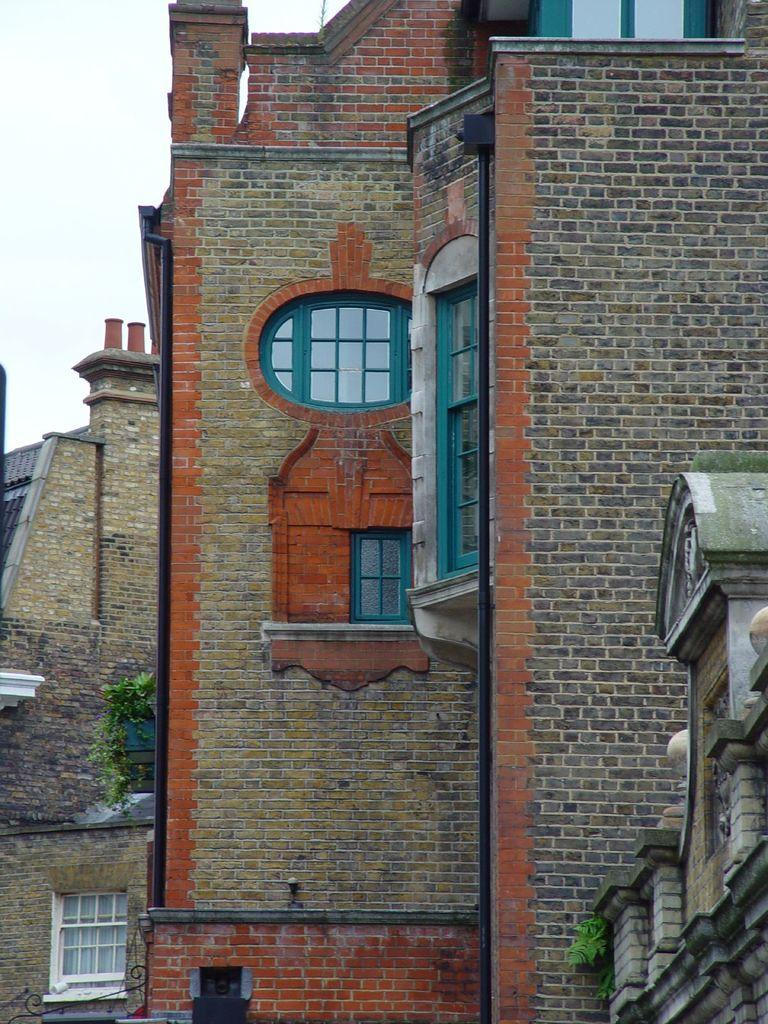What type of structures are visible in the image? There are buildings in the image. What feature do the buildings have? The buildings have windows. Where is the plant located in the image? The plant is on the left side of the image. How many chins are visible on the plant in the image? There are no chins present in the image, as it features buildings and a plant, not any living beings with chins. 